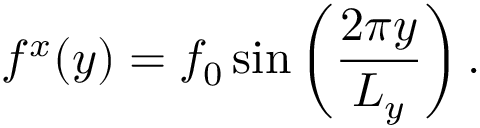Convert formula to latex. <formula><loc_0><loc_0><loc_500><loc_500>f ^ { x } ( y ) = f _ { 0 } \sin \left ( { \frac { 2 \pi y } { L _ { y } } } \right ) .</formula> 